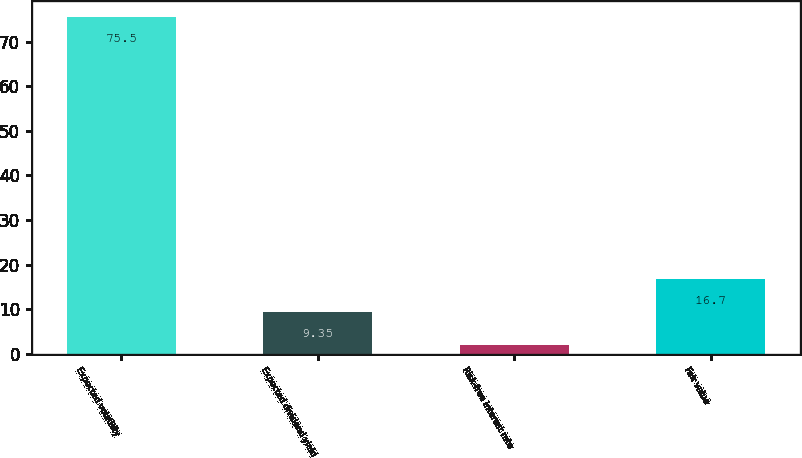Convert chart. <chart><loc_0><loc_0><loc_500><loc_500><bar_chart><fcel>Expected volatility<fcel>Expected dividend yield<fcel>Risk-free interest rate<fcel>Fair value<nl><fcel>75.5<fcel>9.35<fcel>2<fcel>16.7<nl></chart> 